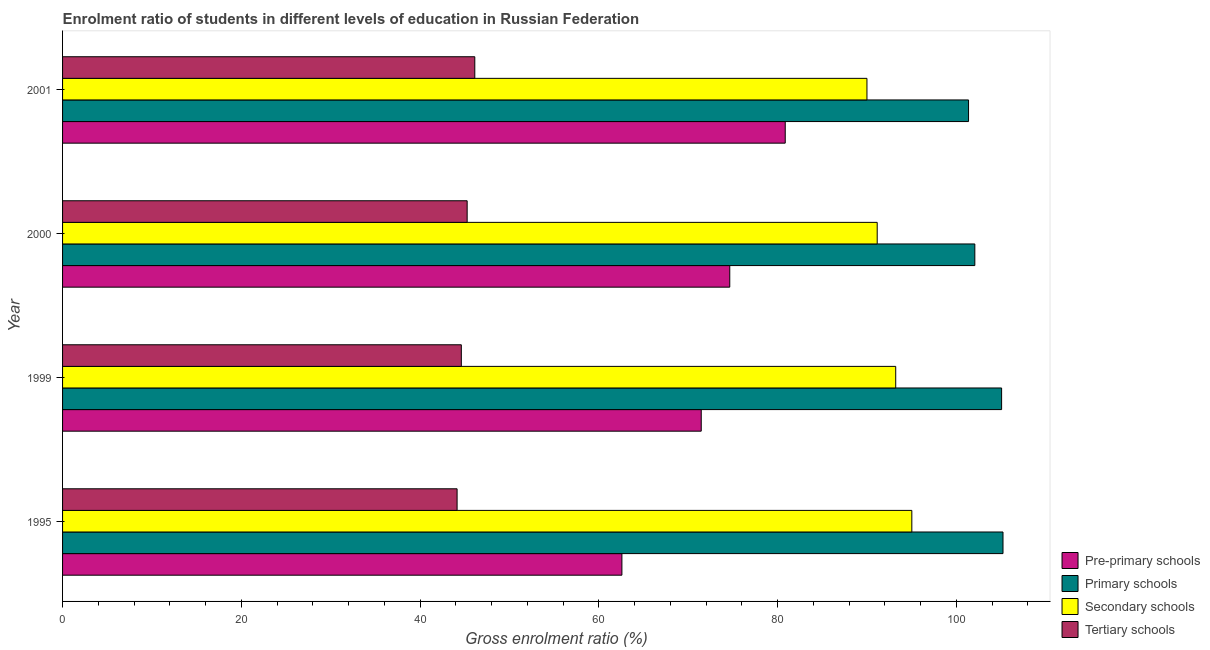How many groups of bars are there?
Give a very brief answer. 4. What is the label of the 2nd group of bars from the top?
Ensure brevity in your answer.  2000. In how many cases, is the number of bars for a given year not equal to the number of legend labels?
Your response must be concise. 0. What is the gross enrolment ratio in primary schools in 2001?
Ensure brevity in your answer.  101.37. Across all years, what is the maximum gross enrolment ratio in pre-primary schools?
Keep it short and to the point. 80.86. Across all years, what is the minimum gross enrolment ratio in secondary schools?
Your response must be concise. 90.01. In which year was the gross enrolment ratio in secondary schools maximum?
Your answer should be compact. 1995. What is the total gross enrolment ratio in secondary schools in the graph?
Provide a succinct answer. 369.42. What is the difference between the gross enrolment ratio in tertiary schools in 1995 and that in 2001?
Your answer should be compact. -1.98. What is the difference between the gross enrolment ratio in tertiary schools in 2000 and the gross enrolment ratio in pre-primary schools in 1999?
Provide a short and direct response. -26.19. What is the average gross enrolment ratio in secondary schools per year?
Offer a terse response. 92.35. In the year 1995, what is the difference between the gross enrolment ratio in pre-primary schools and gross enrolment ratio in tertiary schools?
Ensure brevity in your answer.  18.44. What is the ratio of the gross enrolment ratio in pre-primary schools in 1995 to that in 2000?
Your answer should be very brief. 0.84. Is the gross enrolment ratio in secondary schools in 1999 less than that in 2001?
Provide a short and direct response. No. Is the difference between the gross enrolment ratio in tertiary schools in 1995 and 2000 greater than the difference between the gross enrolment ratio in secondary schools in 1995 and 2000?
Give a very brief answer. No. What is the difference between the highest and the second highest gross enrolment ratio in pre-primary schools?
Make the answer very short. 6.21. What is the difference between the highest and the lowest gross enrolment ratio in primary schools?
Give a very brief answer. 3.86. In how many years, is the gross enrolment ratio in secondary schools greater than the average gross enrolment ratio in secondary schools taken over all years?
Offer a terse response. 2. Is it the case that in every year, the sum of the gross enrolment ratio in secondary schools and gross enrolment ratio in pre-primary schools is greater than the sum of gross enrolment ratio in primary schools and gross enrolment ratio in tertiary schools?
Give a very brief answer. No. What does the 2nd bar from the top in 1999 represents?
Provide a succinct answer. Secondary schools. What does the 3rd bar from the bottom in 2001 represents?
Provide a short and direct response. Secondary schools. Are all the bars in the graph horizontal?
Offer a terse response. Yes. How many years are there in the graph?
Make the answer very short. 4. Are the values on the major ticks of X-axis written in scientific E-notation?
Provide a short and direct response. No. Does the graph contain any zero values?
Keep it short and to the point. No. Does the graph contain grids?
Your answer should be very brief. No. How many legend labels are there?
Your answer should be compact. 4. How are the legend labels stacked?
Provide a succinct answer. Vertical. What is the title of the graph?
Your answer should be compact. Enrolment ratio of students in different levels of education in Russian Federation. Does "Rule based governance" appear as one of the legend labels in the graph?
Your answer should be very brief. No. What is the label or title of the X-axis?
Offer a terse response. Gross enrolment ratio (%). What is the Gross enrolment ratio (%) in Pre-primary schools in 1995?
Offer a very short reply. 62.59. What is the Gross enrolment ratio (%) in Primary schools in 1995?
Ensure brevity in your answer.  105.23. What is the Gross enrolment ratio (%) in Secondary schools in 1995?
Make the answer very short. 95.03. What is the Gross enrolment ratio (%) in Tertiary schools in 1995?
Your answer should be compact. 44.15. What is the Gross enrolment ratio (%) in Pre-primary schools in 1999?
Offer a very short reply. 71.46. What is the Gross enrolment ratio (%) of Primary schools in 1999?
Offer a very short reply. 105.07. What is the Gross enrolment ratio (%) of Secondary schools in 1999?
Provide a succinct answer. 93.23. What is the Gross enrolment ratio (%) of Tertiary schools in 1999?
Keep it short and to the point. 44.62. What is the Gross enrolment ratio (%) of Pre-primary schools in 2000?
Offer a very short reply. 74.66. What is the Gross enrolment ratio (%) in Primary schools in 2000?
Your answer should be compact. 102.08. What is the Gross enrolment ratio (%) in Secondary schools in 2000?
Provide a short and direct response. 91.15. What is the Gross enrolment ratio (%) in Tertiary schools in 2000?
Make the answer very short. 45.27. What is the Gross enrolment ratio (%) in Pre-primary schools in 2001?
Provide a succinct answer. 80.86. What is the Gross enrolment ratio (%) in Primary schools in 2001?
Make the answer very short. 101.37. What is the Gross enrolment ratio (%) of Secondary schools in 2001?
Offer a very short reply. 90.01. What is the Gross enrolment ratio (%) of Tertiary schools in 2001?
Offer a very short reply. 46.13. Across all years, what is the maximum Gross enrolment ratio (%) in Pre-primary schools?
Your response must be concise. 80.86. Across all years, what is the maximum Gross enrolment ratio (%) in Primary schools?
Your response must be concise. 105.23. Across all years, what is the maximum Gross enrolment ratio (%) in Secondary schools?
Your response must be concise. 95.03. Across all years, what is the maximum Gross enrolment ratio (%) of Tertiary schools?
Ensure brevity in your answer.  46.13. Across all years, what is the minimum Gross enrolment ratio (%) in Pre-primary schools?
Give a very brief answer. 62.59. Across all years, what is the minimum Gross enrolment ratio (%) of Primary schools?
Your response must be concise. 101.37. Across all years, what is the minimum Gross enrolment ratio (%) of Secondary schools?
Make the answer very short. 90.01. Across all years, what is the minimum Gross enrolment ratio (%) of Tertiary schools?
Keep it short and to the point. 44.15. What is the total Gross enrolment ratio (%) in Pre-primary schools in the graph?
Provide a short and direct response. 289.57. What is the total Gross enrolment ratio (%) in Primary schools in the graph?
Ensure brevity in your answer.  413.76. What is the total Gross enrolment ratio (%) of Secondary schools in the graph?
Offer a terse response. 369.42. What is the total Gross enrolment ratio (%) in Tertiary schools in the graph?
Provide a succinct answer. 180.16. What is the difference between the Gross enrolment ratio (%) in Pre-primary schools in 1995 and that in 1999?
Keep it short and to the point. -8.88. What is the difference between the Gross enrolment ratio (%) in Primary schools in 1995 and that in 1999?
Offer a terse response. 0.16. What is the difference between the Gross enrolment ratio (%) in Secondary schools in 1995 and that in 1999?
Provide a short and direct response. 1.8. What is the difference between the Gross enrolment ratio (%) in Tertiary schools in 1995 and that in 1999?
Keep it short and to the point. -0.47. What is the difference between the Gross enrolment ratio (%) of Pre-primary schools in 1995 and that in 2000?
Your answer should be compact. -12.07. What is the difference between the Gross enrolment ratio (%) of Primary schools in 1995 and that in 2000?
Make the answer very short. 3.15. What is the difference between the Gross enrolment ratio (%) in Secondary schools in 1995 and that in 2000?
Make the answer very short. 3.87. What is the difference between the Gross enrolment ratio (%) of Tertiary schools in 1995 and that in 2000?
Offer a terse response. -1.13. What is the difference between the Gross enrolment ratio (%) of Pre-primary schools in 1995 and that in 2001?
Your answer should be very brief. -18.28. What is the difference between the Gross enrolment ratio (%) of Primary schools in 1995 and that in 2001?
Your answer should be very brief. 3.86. What is the difference between the Gross enrolment ratio (%) in Secondary schools in 1995 and that in 2001?
Your response must be concise. 5.02. What is the difference between the Gross enrolment ratio (%) in Tertiary schools in 1995 and that in 2001?
Give a very brief answer. -1.98. What is the difference between the Gross enrolment ratio (%) of Pre-primary schools in 1999 and that in 2000?
Make the answer very short. -3.19. What is the difference between the Gross enrolment ratio (%) of Primary schools in 1999 and that in 2000?
Keep it short and to the point. 3. What is the difference between the Gross enrolment ratio (%) of Secondary schools in 1999 and that in 2000?
Your answer should be compact. 2.07. What is the difference between the Gross enrolment ratio (%) in Tertiary schools in 1999 and that in 2000?
Keep it short and to the point. -0.65. What is the difference between the Gross enrolment ratio (%) of Pre-primary schools in 1999 and that in 2001?
Your answer should be compact. -9.4. What is the difference between the Gross enrolment ratio (%) in Primary schools in 1999 and that in 2001?
Provide a succinct answer. 3.7. What is the difference between the Gross enrolment ratio (%) in Secondary schools in 1999 and that in 2001?
Provide a short and direct response. 3.22. What is the difference between the Gross enrolment ratio (%) in Tertiary schools in 1999 and that in 2001?
Keep it short and to the point. -1.51. What is the difference between the Gross enrolment ratio (%) of Pre-primary schools in 2000 and that in 2001?
Your response must be concise. -6.21. What is the difference between the Gross enrolment ratio (%) of Primary schools in 2000 and that in 2001?
Ensure brevity in your answer.  0.7. What is the difference between the Gross enrolment ratio (%) of Secondary schools in 2000 and that in 2001?
Make the answer very short. 1.15. What is the difference between the Gross enrolment ratio (%) of Tertiary schools in 2000 and that in 2001?
Make the answer very short. -0.86. What is the difference between the Gross enrolment ratio (%) in Pre-primary schools in 1995 and the Gross enrolment ratio (%) in Primary schools in 1999?
Provide a succinct answer. -42.49. What is the difference between the Gross enrolment ratio (%) in Pre-primary schools in 1995 and the Gross enrolment ratio (%) in Secondary schools in 1999?
Provide a succinct answer. -30.64. What is the difference between the Gross enrolment ratio (%) of Pre-primary schools in 1995 and the Gross enrolment ratio (%) of Tertiary schools in 1999?
Ensure brevity in your answer.  17.97. What is the difference between the Gross enrolment ratio (%) in Primary schools in 1995 and the Gross enrolment ratio (%) in Secondary schools in 1999?
Give a very brief answer. 12. What is the difference between the Gross enrolment ratio (%) of Primary schools in 1995 and the Gross enrolment ratio (%) of Tertiary schools in 1999?
Offer a very short reply. 60.61. What is the difference between the Gross enrolment ratio (%) in Secondary schools in 1995 and the Gross enrolment ratio (%) in Tertiary schools in 1999?
Make the answer very short. 50.41. What is the difference between the Gross enrolment ratio (%) of Pre-primary schools in 1995 and the Gross enrolment ratio (%) of Primary schools in 2000?
Your answer should be compact. -39.49. What is the difference between the Gross enrolment ratio (%) of Pre-primary schools in 1995 and the Gross enrolment ratio (%) of Secondary schools in 2000?
Provide a short and direct response. -28.57. What is the difference between the Gross enrolment ratio (%) in Pre-primary schools in 1995 and the Gross enrolment ratio (%) in Tertiary schools in 2000?
Provide a short and direct response. 17.32. What is the difference between the Gross enrolment ratio (%) in Primary schools in 1995 and the Gross enrolment ratio (%) in Secondary schools in 2000?
Ensure brevity in your answer.  14.08. What is the difference between the Gross enrolment ratio (%) in Primary schools in 1995 and the Gross enrolment ratio (%) in Tertiary schools in 2000?
Ensure brevity in your answer.  59.96. What is the difference between the Gross enrolment ratio (%) of Secondary schools in 1995 and the Gross enrolment ratio (%) of Tertiary schools in 2000?
Ensure brevity in your answer.  49.76. What is the difference between the Gross enrolment ratio (%) in Pre-primary schools in 1995 and the Gross enrolment ratio (%) in Primary schools in 2001?
Your response must be concise. -38.79. What is the difference between the Gross enrolment ratio (%) in Pre-primary schools in 1995 and the Gross enrolment ratio (%) in Secondary schools in 2001?
Make the answer very short. -27.42. What is the difference between the Gross enrolment ratio (%) in Pre-primary schools in 1995 and the Gross enrolment ratio (%) in Tertiary schools in 2001?
Give a very brief answer. 16.46. What is the difference between the Gross enrolment ratio (%) of Primary schools in 1995 and the Gross enrolment ratio (%) of Secondary schools in 2001?
Ensure brevity in your answer.  15.22. What is the difference between the Gross enrolment ratio (%) in Primary schools in 1995 and the Gross enrolment ratio (%) in Tertiary schools in 2001?
Your answer should be very brief. 59.1. What is the difference between the Gross enrolment ratio (%) of Secondary schools in 1995 and the Gross enrolment ratio (%) of Tertiary schools in 2001?
Your answer should be compact. 48.9. What is the difference between the Gross enrolment ratio (%) of Pre-primary schools in 1999 and the Gross enrolment ratio (%) of Primary schools in 2000?
Offer a terse response. -30.61. What is the difference between the Gross enrolment ratio (%) of Pre-primary schools in 1999 and the Gross enrolment ratio (%) of Secondary schools in 2000?
Provide a short and direct response. -19.69. What is the difference between the Gross enrolment ratio (%) in Pre-primary schools in 1999 and the Gross enrolment ratio (%) in Tertiary schools in 2000?
Ensure brevity in your answer.  26.19. What is the difference between the Gross enrolment ratio (%) of Primary schools in 1999 and the Gross enrolment ratio (%) of Secondary schools in 2000?
Your answer should be very brief. 13.92. What is the difference between the Gross enrolment ratio (%) of Primary schools in 1999 and the Gross enrolment ratio (%) of Tertiary schools in 2000?
Keep it short and to the point. 59.8. What is the difference between the Gross enrolment ratio (%) in Secondary schools in 1999 and the Gross enrolment ratio (%) in Tertiary schools in 2000?
Provide a short and direct response. 47.95. What is the difference between the Gross enrolment ratio (%) in Pre-primary schools in 1999 and the Gross enrolment ratio (%) in Primary schools in 2001?
Your answer should be very brief. -29.91. What is the difference between the Gross enrolment ratio (%) of Pre-primary schools in 1999 and the Gross enrolment ratio (%) of Secondary schools in 2001?
Offer a very short reply. -18.54. What is the difference between the Gross enrolment ratio (%) of Pre-primary schools in 1999 and the Gross enrolment ratio (%) of Tertiary schools in 2001?
Your answer should be compact. 25.34. What is the difference between the Gross enrolment ratio (%) of Primary schools in 1999 and the Gross enrolment ratio (%) of Secondary schools in 2001?
Your answer should be compact. 15.07. What is the difference between the Gross enrolment ratio (%) in Primary schools in 1999 and the Gross enrolment ratio (%) in Tertiary schools in 2001?
Make the answer very short. 58.95. What is the difference between the Gross enrolment ratio (%) of Secondary schools in 1999 and the Gross enrolment ratio (%) of Tertiary schools in 2001?
Offer a very short reply. 47.1. What is the difference between the Gross enrolment ratio (%) in Pre-primary schools in 2000 and the Gross enrolment ratio (%) in Primary schools in 2001?
Offer a terse response. -26.72. What is the difference between the Gross enrolment ratio (%) of Pre-primary schools in 2000 and the Gross enrolment ratio (%) of Secondary schools in 2001?
Keep it short and to the point. -15.35. What is the difference between the Gross enrolment ratio (%) of Pre-primary schools in 2000 and the Gross enrolment ratio (%) of Tertiary schools in 2001?
Provide a short and direct response. 28.53. What is the difference between the Gross enrolment ratio (%) of Primary schools in 2000 and the Gross enrolment ratio (%) of Secondary schools in 2001?
Your response must be concise. 12.07. What is the difference between the Gross enrolment ratio (%) in Primary schools in 2000 and the Gross enrolment ratio (%) in Tertiary schools in 2001?
Provide a short and direct response. 55.95. What is the difference between the Gross enrolment ratio (%) in Secondary schools in 2000 and the Gross enrolment ratio (%) in Tertiary schools in 2001?
Provide a succinct answer. 45.03. What is the average Gross enrolment ratio (%) of Pre-primary schools per year?
Provide a short and direct response. 72.39. What is the average Gross enrolment ratio (%) in Primary schools per year?
Give a very brief answer. 103.44. What is the average Gross enrolment ratio (%) in Secondary schools per year?
Ensure brevity in your answer.  92.35. What is the average Gross enrolment ratio (%) of Tertiary schools per year?
Offer a very short reply. 45.04. In the year 1995, what is the difference between the Gross enrolment ratio (%) of Pre-primary schools and Gross enrolment ratio (%) of Primary schools?
Offer a very short reply. -42.64. In the year 1995, what is the difference between the Gross enrolment ratio (%) in Pre-primary schools and Gross enrolment ratio (%) in Secondary schools?
Offer a very short reply. -32.44. In the year 1995, what is the difference between the Gross enrolment ratio (%) of Pre-primary schools and Gross enrolment ratio (%) of Tertiary schools?
Keep it short and to the point. 18.44. In the year 1995, what is the difference between the Gross enrolment ratio (%) in Primary schools and Gross enrolment ratio (%) in Secondary schools?
Your answer should be very brief. 10.2. In the year 1995, what is the difference between the Gross enrolment ratio (%) of Primary schools and Gross enrolment ratio (%) of Tertiary schools?
Keep it short and to the point. 61.09. In the year 1995, what is the difference between the Gross enrolment ratio (%) of Secondary schools and Gross enrolment ratio (%) of Tertiary schools?
Provide a succinct answer. 50.88. In the year 1999, what is the difference between the Gross enrolment ratio (%) of Pre-primary schools and Gross enrolment ratio (%) of Primary schools?
Keep it short and to the point. -33.61. In the year 1999, what is the difference between the Gross enrolment ratio (%) of Pre-primary schools and Gross enrolment ratio (%) of Secondary schools?
Make the answer very short. -21.76. In the year 1999, what is the difference between the Gross enrolment ratio (%) of Pre-primary schools and Gross enrolment ratio (%) of Tertiary schools?
Your answer should be compact. 26.84. In the year 1999, what is the difference between the Gross enrolment ratio (%) of Primary schools and Gross enrolment ratio (%) of Secondary schools?
Give a very brief answer. 11.85. In the year 1999, what is the difference between the Gross enrolment ratio (%) of Primary schools and Gross enrolment ratio (%) of Tertiary schools?
Ensure brevity in your answer.  60.45. In the year 1999, what is the difference between the Gross enrolment ratio (%) of Secondary schools and Gross enrolment ratio (%) of Tertiary schools?
Offer a very short reply. 48.61. In the year 2000, what is the difference between the Gross enrolment ratio (%) in Pre-primary schools and Gross enrolment ratio (%) in Primary schools?
Provide a short and direct response. -27.42. In the year 2000, what is the difference between the Gross enrolment ratio (%) of Pre-primary schools and Gross enrolment ratio (%) of Secondary schools?
Your answer should be compact. -16.5. In the year 2000, what is the difference between the Gross enrolment ratio (%) of Pre-primary schools and Gross enrolment ratio (%) of Tertiary schools?
Make the answer very short. 29.39. In the year 2000, what is the difference between the Gross enrolment ratio (%) in Primary schools and Gross enrolment ratio (%) in Secondary schools?
Offer a terse response. 10.92. In the year 2000, what is the difference between the Gross enrolment ratio (%) of Primary schools and Gross enrolment ratio (%) of Tertiary schools?
Offer a terse response. 56.81. In the year 2000, what is the difference between the Gross enrolment ratio (%) in Secondary schools and Gross enrolment ratio (%) in Tertiary schools?
Keep it short and to the point. 45.88. In the year 2001, what is the difference between the Gross enrolment ratio (%) of Pre-primary schools and Gross enrolment ratio (%) of Primary schools?
Your answer should be compact. -20.51. In the year 2001, what is the difference between the Gross enrolment ratio (%) in Pre-primary schools and Gross enrolment ratio (%) in Secondary schools?
Your answer should be very brief. -9.14. In the year 2001, what is the difference between the Gross enrolment ratio (%) of Pre-primary schools and Gross enrolment ratio (%) of Tertiary schools?
Make the answer very short. 34.74. In the year 2001, what is the difference between the Gross enrolment ratio (%) in Primary schools and Gross enrolment ratio (%) in Secondary schools?
Offer a terse response. 11.37. In the year 2001, what is the difference between the Gross enrolment ratio (%) in Primary schools and Gross enrolment ratio (%) in Tertiary schools?
Provide a short and direct response. 55.25. In the year 2001, what is the difference between the Gross enrolment ratio (%) in Secondary schools and Gross enrolment ratio (%) in Tertiary schools?
Your answer should be very brief. 43.88. What is the ratio of the Gross enrolment ratio (%) in Pre-primary schools in 1995 to that in 1999?
Ensure brevity in your answer.  0.88. What is the ratio of the Gross enrolment ratio (%) in Primary schools in 1995 to that in 1999?
Keep it short and to the point. 1. What is the ratio of the Gross enrolment ratio (%) of Secondary schools in 1995 to that in 1999?
Make the answer very short. 1.02. What is the ratio of the Gross enrolment ratio (%) of Tertiary schools in 1995 to that in 1999?
Make the answer very short. 0.99. What is the ratio of the Gross enrolment ratio (%) of Pre-primary schools in 1995 to that in 2000?
Your response must be concise. 0.84. What is the ratio of the Gross enrolment ratio (%) in Primary schools in 1995 to that in 2000?
Give a very brief answer. 1.03. What is the ratio of the Gross enrolment ratio (%) of Secondary schools in 1995 to that in 2000?
Your answer should be compact. 1.04. What is the ratio of the Gross enrolment ratio (%) in Tertiary schools in 1995 to that in 2000?
Provide a short and direct response. 0.98. What is the ratio of the Gross enrolment ratio (%) of Pre-primary schools in 1995 to that in 2001?
Offer a terse response. 0.77. What is the ratio of the Gross enrolment ratio (%) in Primary schools in 1995 to that in 2001?
Ensure brevity in your answer.  1.04. What is the ratio of the Gross enrolment ratio (%) in Secondary schools in 1995 to that in 2001?
Your answer should be compact. 1.06. What is the ratio of the Gross enrolment ratio (%) of Tertiary schools in 1995 to that in 2001?
Give a very brief answer. 0.96. What is the ratio of the Gross enrolment ratio (%) in Pre-primary schools in 1999 to that in 2000?
Give a very brief answer. 0.96. What is the ratio of the Gross enrolment ratio (%) of Primary schools in 1999 to that in 2000?
Offer a terse response. 1.03. What is the ratio of the Gross enrolment ratio (%) of Secondary schools in 1999 to that in 2000?
Offer a very short reply. 1.02. What is the ratio of the Gross enrolment ratio (%) in Tertiary schools in 1999 to that in 2000?
Keep it short and to the point. 0.99. What is the ratio of the Gross enrolment ratio (%) of Pre-primary schools in 1999 to that in 2001?
Keep it short and to the point. 0.88. What is the ratio of the Gross enrolment ratio (%) in Primary schools in 1999 to that in 2001?
Offer a very short reply. 1.04. What is the ratio of the Gross enrolment ratio (%) of Secondary schools in 1999 to that in 2001?
Give a very brief answer. 1.04. What is the ratio of the Gross enrolment ratio (%) of Tertiary schools in 1999 to that in 2001?
Offer a very short reply. 0.97. What is the ratio of the Gross enrolment ratio (%) of Pre-primary schools in 2000 to that in 2001?
Offer a very short reply. 0.92. What is the ratio of the Gross enrolment ratio (%) of Secondary schools in 2000 to that in 2001?
Your response must be concise. 1.01. What is the ratio of the Gross enrolment ratio (%) of Tertiary schools in 2000 to that in 2001?
Keep it short and to the point. 0.98. What is the difference between the highest and the second highest Gross enrolment ratio (%) of Pre-primary schools?
Your answer should be very brief. 6.21. What is the difference between the highest and the second highest Gross enrolment ratio (%) of Primary schools?
Your answer should be compact. 0.16. What is the difference between the highest and the second highest Gross enrolment ratio (%) in Secondary schools?
Your response must be concise. 1.8. What is the difference between the highest and the second highest Gross enrolment ratio (%) of Tertiary schools?
Keep it short and to the point. 0.86. What is the difference between the highest and the lowest Gross enrolment ratio (%) of Pre-primary schools?
Provide a succinct answer. 18.28. What is the difference between the highest and the lowest Gross enrolment ratio (%) of Primary schools?
Your response must be concise. 3.86. What is the difference between the highest and the lowest Gross enrolment ratio (%) of Secondary schools?
Ensure brevity in your answer.  5.02. What is the difference between the highest and the lowest Gross enrolment ratio (%) in Tertiary schools?
Make the answer very short. 1.98. 